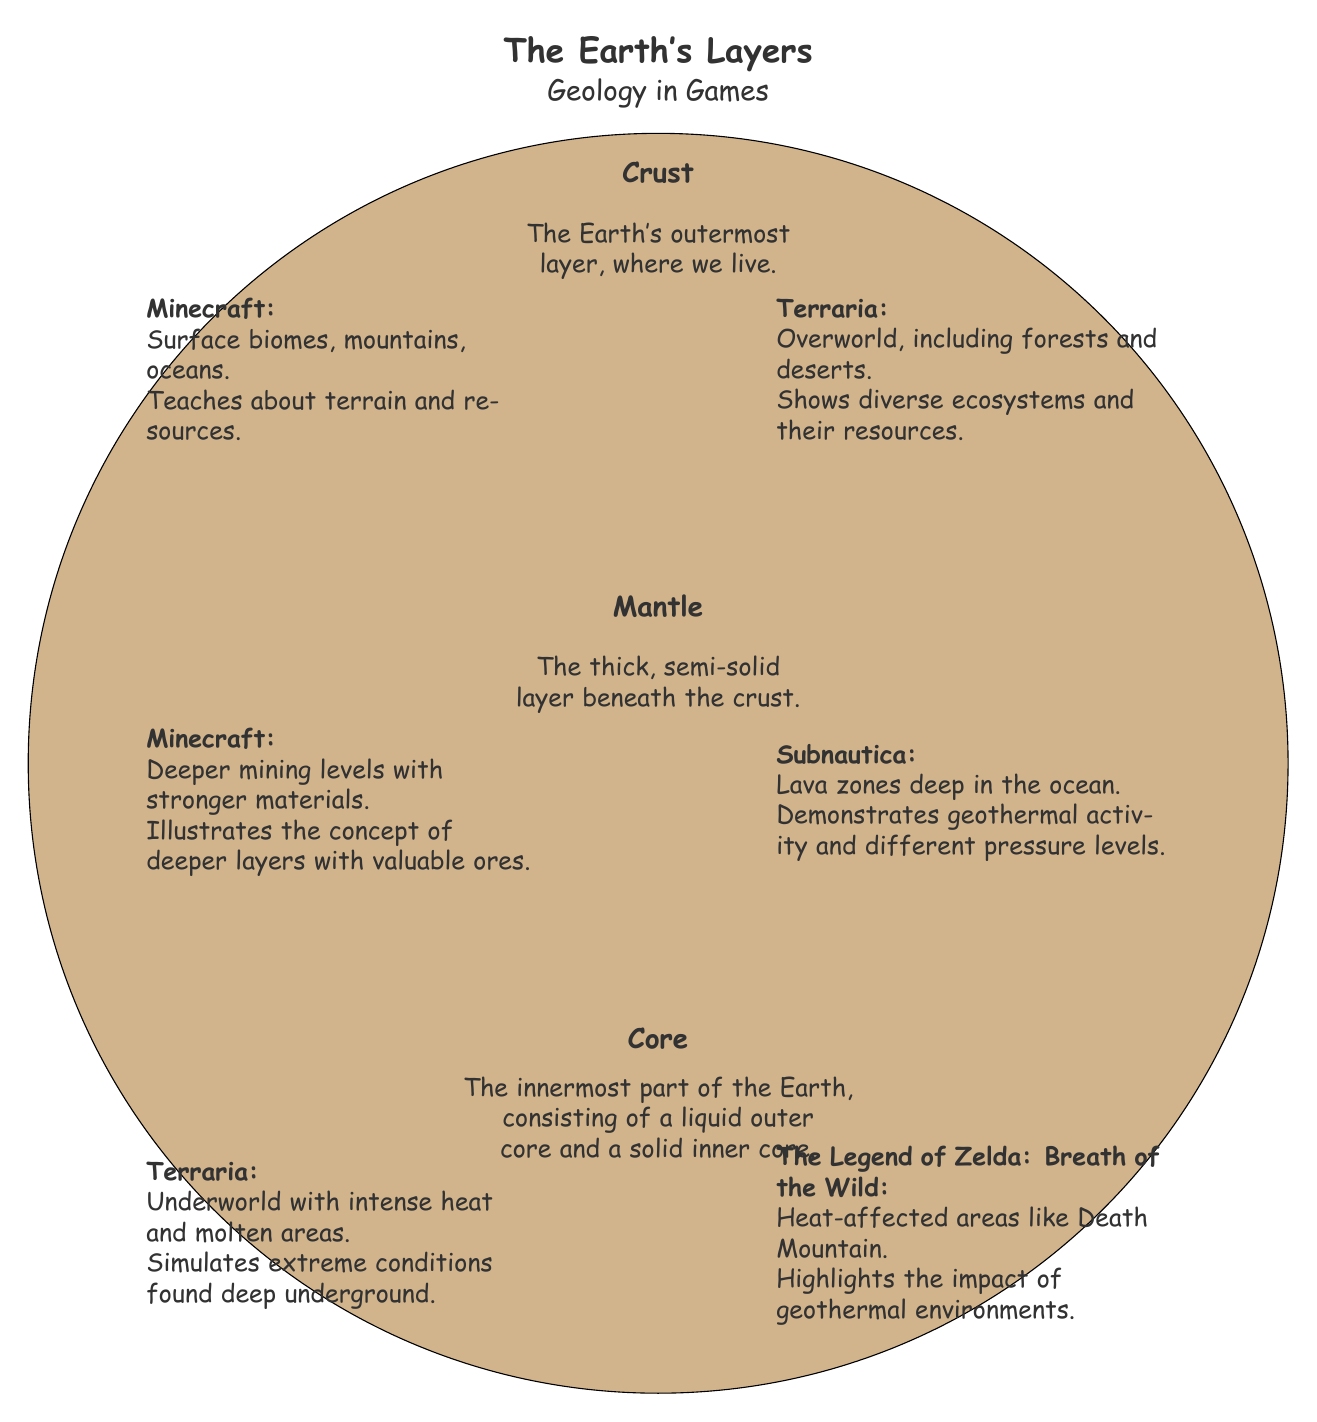What are the three main layers of the Earth depicted in the diagram? The diagram clearly shows three layers: the Crust, Mantle, and Core. These labels are prominently displayed in the diagram.
Answer: Crust, Mantle, Core Which layer is the Earth's outermost? The diagram specifies that the Crust is the outermost layer, as noted in the labeling and description sections.
Answer: Crust What educational game represents the Mantle layer? The diagram lists "Minecraft" and "Subnautica" as examples that illustrate various aspects of the Mantle layer, but "Subnautica" is specifically mentioned as demonstrating geothermal activity and pressure levels unique to deeper layers.
Answer: Subnautica Which game illustrates extreme conditions related to the Core? The game "Terraria" is specifically mentioned in the diagram's Core section as simulating intense heat and molten areas related to the Core, as it is described under the Core layer.
Answer: Terraria How many games are listed under the Crust section? The Crust section lists two games, "Minecraft" and "Terraria," which are explicitly mentioned in the description for that layer.
Answer: 2 Which layer has the description "A thick, semi-solid layer beneath the crust"? Referring to the provided descriptions, this phrase is used specifically for the Mantle layer, thereby establishing its characteristics relative to the Crust above it.
Answer: Mantle What color represents the Core in the diagram? The Core is depicted in a bright reddish color which is defined as "RGB (255,69,0)" in the diagram code, illustrating its position and importance visually.
Answer: RGB (255,69,0) How does “Minecraft” educate about the Crust? The Crust section describes "Minecraft" as teaching about surface biomes, mountains, and oceans, thereby helping players understand the terrain and resources in the game.
Answer: Surface biomes, mountains, oceans Which game shows diverse ecosystems related to the Crust? "Terraria" is specifically highlighted in the Crust section for showing diverse ecosystems such as forests and deserts, making it a key reference for that layer.
Answer: Terraria What is the relationship between the Crust and Mantle layers based on the diagram? The diagram indicates that the Crust is the outermost layer, while the Mantle lies directly beneath it, establishing a clear structural relationship where the Mantle supports the Crust above.
Answer: Crust supports Mantle 